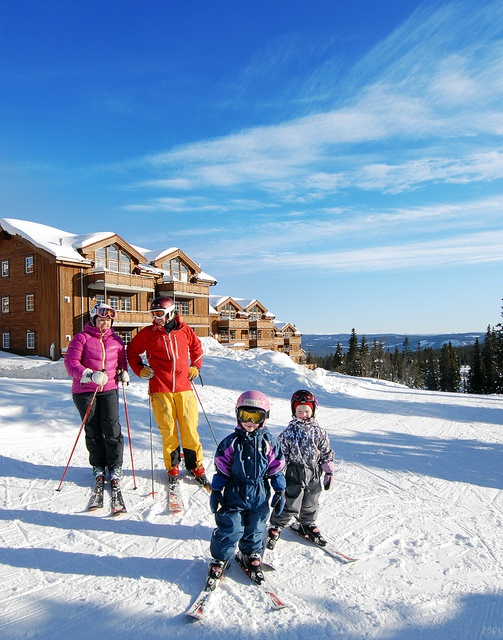Describe the objects in this image and their specific colors. I can see people in blue, black, navy, and gray tones, people in blue, black, violet, purple, and gray tones, people in blue, maroon, orange, and salmon tones, people in blue, black, gray, darkgray, and lightgray tones, and skis in blue, lightgray, darkgray, and gray tones in this image. 